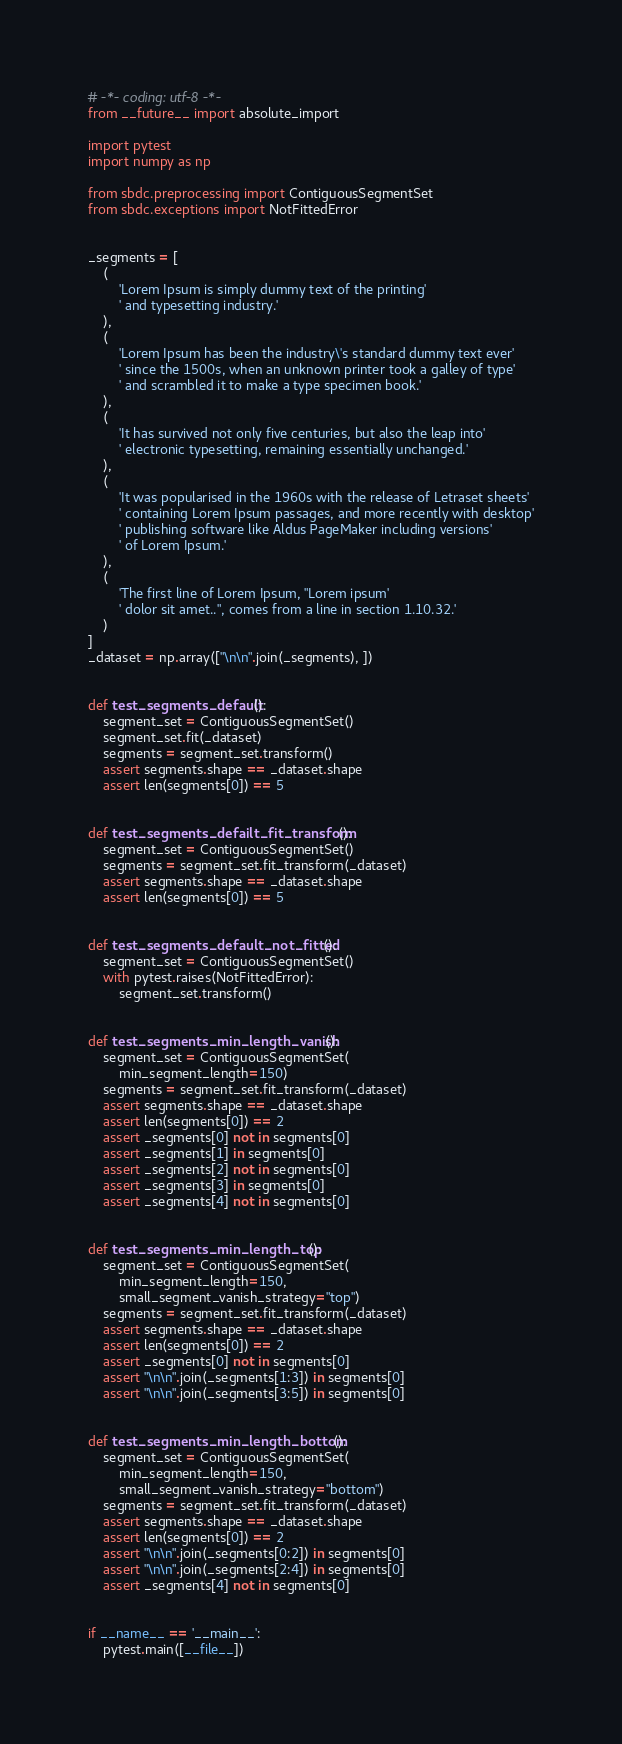Convert code to text. <code><loc_0><loc_0><loc_500><loc_500><_Python_># -*- coding: utf-8 -*-
from __future__ import absolute_import

import pytest
import numpy as np

from sbdc.preprocessing import ContiguousSegmentSet
from sbdc.exceptions import NotFittedError


_segments = [
    (
        'Lorem Ipsum is simply dummy text of the printing'
        ' and typesetting industry.'
    ),
    (
        'Lorem Ipsum has been the industry\'s standard dummy text ever'
        ' since the 1500s, when an unknown printer took a galley of type'
        ' and scrambled it to make a type specimen book.'
    ),
    (
        'It has survived not only five centuries, but also the leap into'
        ' electronic typesetting, remaining essentially unchanged.'
    ),
    (
        'It was popularised in the 1960s with the release of Letraset sheets'
        ' containing Lorem Ipsum passages, and more recently with desktop'
        ' publishing software like Aldus PageMaker including versions'
        ' of Lorem Ipsum.'
    ),
    (
        'The first line of Lorem Ipsum, "Lorem ipsum'
        ' dolor sit amet..", comes from a line in section 1.10.32.'
    )
]
_dataset = np.array(["\n\n".join(_segments), ])


def test_segments_default():
    segment_set = ContiguousSegmentSet()
    segment_set.fit(_dataset)
    segments = segment_set.transform()
    assert segments.shape == _dataset.shape
    assert len(segments[0]) == 5


def test_segments_defailt_fit_transform():
    segment_set = ContiguousSegmentSet()
    segments = segment_set.fit_transform(_dataset)
    assert segments.shape == _dataset.shape
    assert len(segments[0]) == 5


def test_segments_default_not_fitted():
    segment_set = ContiguousSegmentSet()
    with pytest.raises(NotFittedError):
        segment_set.transform()


def test_segments_min_length_vanish():
    segment_set = ContiguousSegmentSet(
        min_segment_length=150)
    segments = segment_set.fit_transform(_dataset)
    assert segments.shape == _dataset.shape
    assert len(segments[0]) == 2
    assert _segments[0] not in segments[0]
    assert _segments[1] in segments[0]
    assert _segments[2] not in segments[0]
    assert _segments[3] in segments[0]
    assert _segments[4] not in segments[0]


def test_segments_min_length_top():
    segment_set = ContiguousSegmentSet(
        min_segment_length=150,
        small_segment_vanish_strategy="top")
    segments = segment_set.fit_transform(_dataset)
    assert segments.shape == _dataset.shape
    assert len(segments[0]) == 2
    assert _segments[0] not in segments[0]
    assert "\n\n".join(_segments[1:3]) in segments[0]
    assert "\n\n".join(_segments[3:5]) in segments[0]


def test_segments_min_length_bottom():
    segment_set = ContiguousSegmentSet(
        min_segment_length=150,
        small_segment_vanish_strategy="bottom")
    segments = segment_set.fit_transform(_dataset)
    assert segments.shape == _dataset.shape
    assert len(segments[0]) == 2
    assert "\n\n".join(_segments[0:2]) in segments[0]
    assert "\n\n".join(_segments[2:4]) in segments[0]
    assert _segments[4] not in segments[0]


if __name__ == '__main__':
    pytest.main([__file__])
</code> 